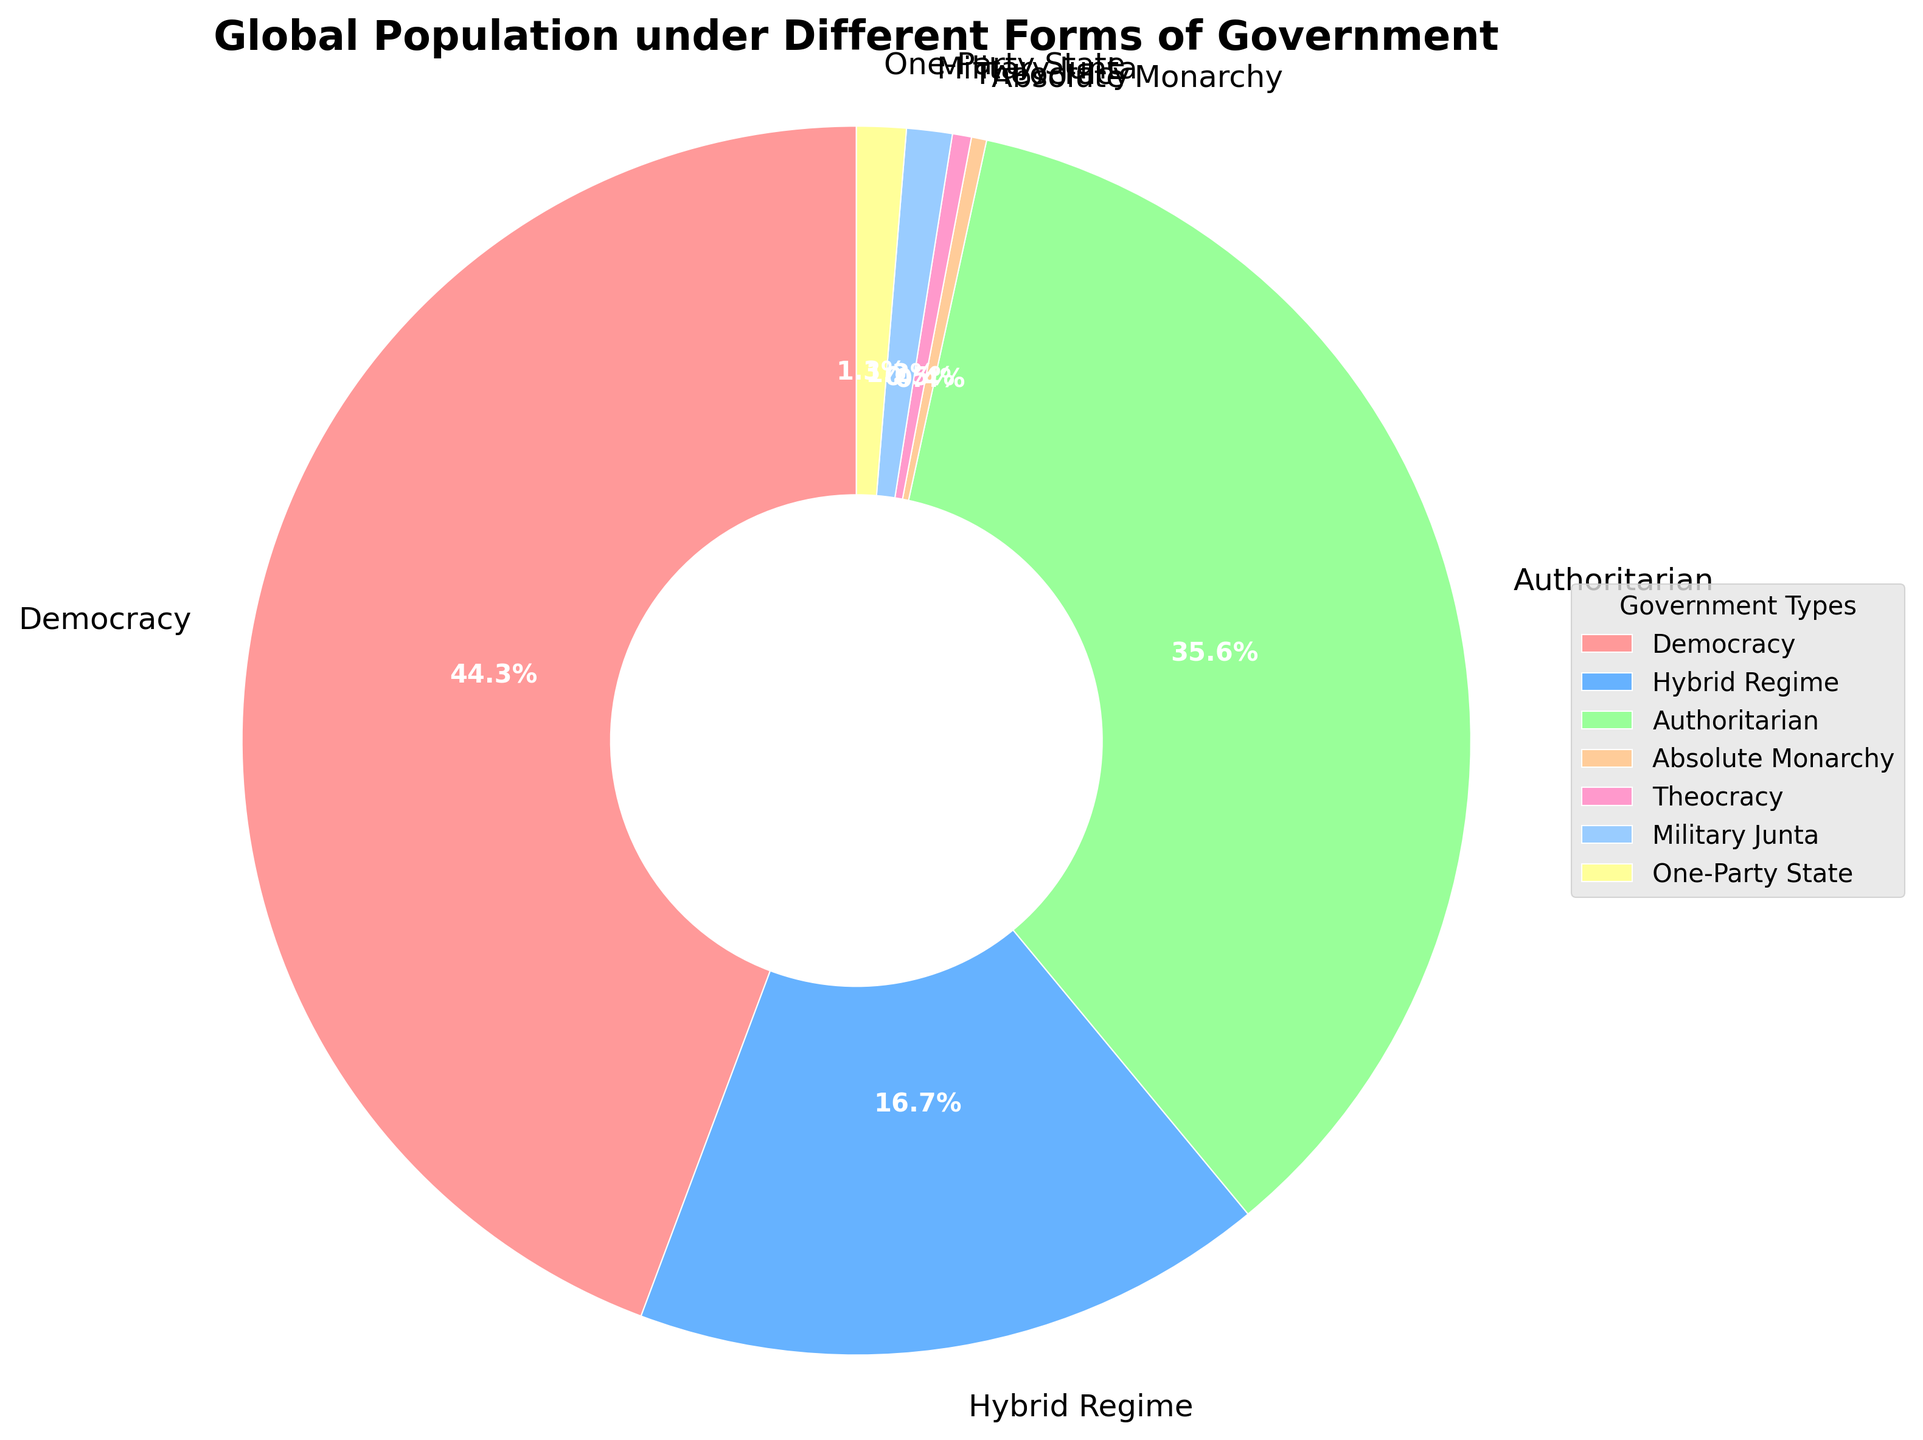What percentage of the global population lives under a form of government other than Democracy or Authoritarian? To find the percentage, first sum the population percentages of Democracy and Authoritarian (44.3% + 35.6% = 79.9%). Then, subtract this from 100% (100% - 79.9% = 20.1%).
Answer: 20.1% Among Hybrid Regime, Military Junta, and One-Party State, which has the lowest percentage? Compare the percentages of Hybrid Regime (16.7%), Military Junta (1.2%), and One-Party State (1.3%). Military Junta has the lowest percentage at 1.2%.
Answer: Military Junta How many percentage points more of the global population live under Democracy compared to Theocracy? Subtract the percentage of Theocracy (0.5%) from Democracy (44.3%). (44.3% - 0.5% = 43.8%).
Answer: 43.8 Which two government types combined make up just over half of the global population? Adding different combinations of two government types to find the total exceeding 50%; Democracy (44.3%) + Authoritarian (35.6%) = 79.9%, which is over half.
Answer: Democracy and Authoritarian What is the percentage difference between Authoritarian and Hybrid Regime? Subtract the percentage of Hybrid Regime (16.7%) from Authoritarian (35.6%). (35.6% - 16.7% = 18.9%).
Answer: 18.9 What is the predominant government type based on the global population? Identify the government type with the highest percentage: Democracy at 44.3%.
Answer: Democracy If you combine the percentages of Absolute Monarchy, Theocracy, Military Junta, and One-Party State, what is the total? Sum up the percentages: 0.4% + 0.5% + 1.2% + 1.3% = 3.4%.
Answer: 3.4 Which government type is represented with the smallest wedge in the pie chart? The government type with the lowest percentage is Absolute Monarchy at 0.4%.
Answer: Absolute Monarchy How does the percentage of the population living under Democracy compare to those under Hybrid Regimes and Authoritarian regimes combined? Sum the percentages of Hybrid Regime and Authoritarian (16.7% + 35.6% = 52.3%). Compare this to Democracy (44.3%). Democracy is less than the combination of the other two (44.3% < 52.3%).
Answer: Less What is the average percentage for the non-democratic government types? Sum the percentages for all non-democratic types (16.7% + 35.6% + 0.4% + 0.5% + 1.2% + 1.3% = 55.7%) and divide by the number of non-democratic types (6). (55.7% ÷ 6 = 9.28%).
Answer: 9.28 